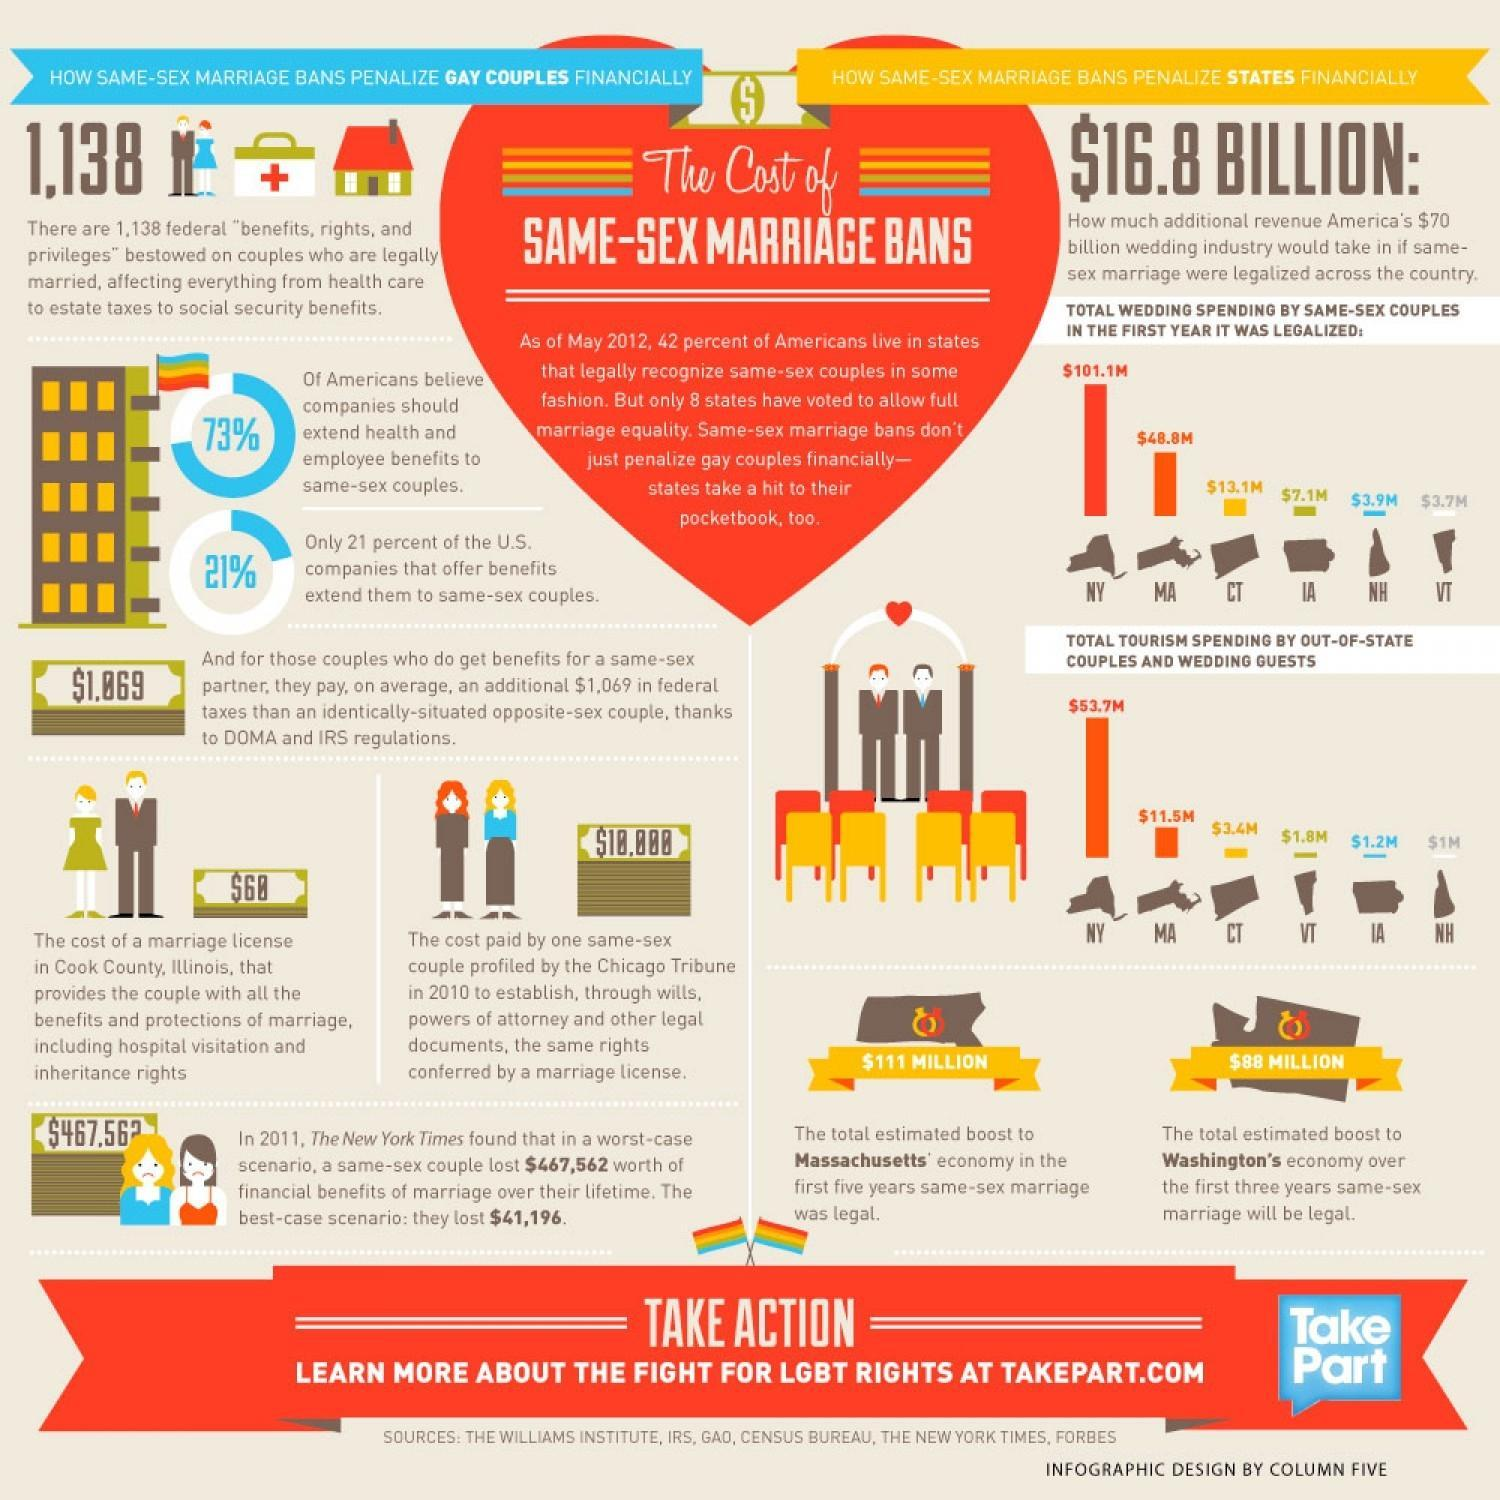What is the total estimated boost to Massachussetts economy in the first five years same sex marriage was legal?
Answer the question with a short phrase. $111 MILLION What percentage of U.S companies do not offer benefits that extend them to same sex couples? 79 What percentage of Americans does not believe, companies should extend benefits to same sex couples? 27 What is the total estimated boost to Washingtons economy in the first three years same sex marriage was legal? $88 MILLION 